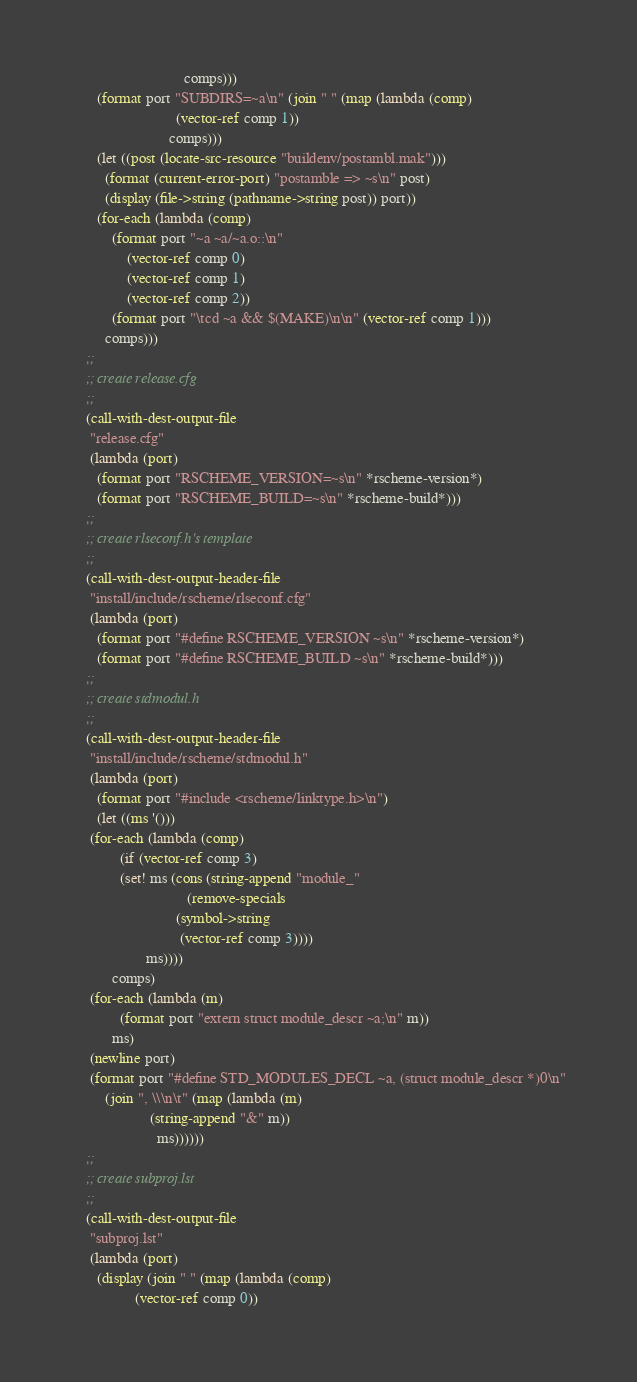<code> <loc_0><loc_0><loc_500><loc_500><_Scheme_>						      comps)))
       (format port "SUBDIRS=~a\n" (join " " (map (lambda (comp)
						    (vector-ref comp 1))
						  comps)))
       (let ((post (locate-src-resource "buildenv/postambl.mak")))
         (format (current-error-port) "postamble => ~s\n" post)
         (display (file->string (pathname->string post)) port))
       (for-each (lambda (comp)
		   (format port "~a ~a/~a.o::\n"
			   (vector-ref comp 0)
			   (vector-ref comp 1)
			   (vector-ref comp 2))
		   (format port "\tcd ~a && $(MAKE)\n\n" (vector-ref comp 1)))
		 comps)))
    ;;
    ;; create release.cfg
    ;;
    (call-with-dest-output-file
     "release.cfg"
     (lambda (port)
       (format port "RSCHEME_VERSION=~s\n" *rscheme-version*)
       (format port "RSCHEME_BUILD=~s\n" *rscheme-build*)))
    ;;
    ;; create rlseconf.h's template
    ;;
    (call-with-dest-output-header-file
     "install/include/rscheme/rlseconf.cfg"
     (lambda (port)
       (format port "#define RSCHEME_VERSION ~s\n" *rscheme-version*)
       (format port "#define RSCHEME_BUILD ~s\n" *rscheme-build*)))
    ;;
    ;; create stdmodul.h
    ;;
    (call-with-dest-output-header-file
     "install/include/rscheme/stdmodul.h"
     (lambda (port)
       (format port "#include <rscheme/linktype.h>\n")
       (let ((ms '()))
	 (for-each (lambda (comp)
		     (if (vector-ref comp 3)
			 (set! ms (cons (string-append "module_"
						       (remove-specials
							(symbol->string
							 (vector-ref comp 3))))
					ms))))
		   comps)
	 (for-each (lambda (m)
		     (format port "extern struct module_descr ~a;\n" m))
		   ms)
	 (newline port)
	 (format port "#define STD_MODULES_DECL ~a, (struct module_descr *)0\n"
		 (join ", \\\n\t" (map (lambda (m)
					 (string-append "&" m))
				       ms))))))
    ;; 
    ;; create subproj.lst
    ;;
    (call-with-dest-output-file
     "subproj.lst"
     (lambda (port)
       (display (join " " (map (lambda (comp)
				 (vector-ref comp 0))</code> 